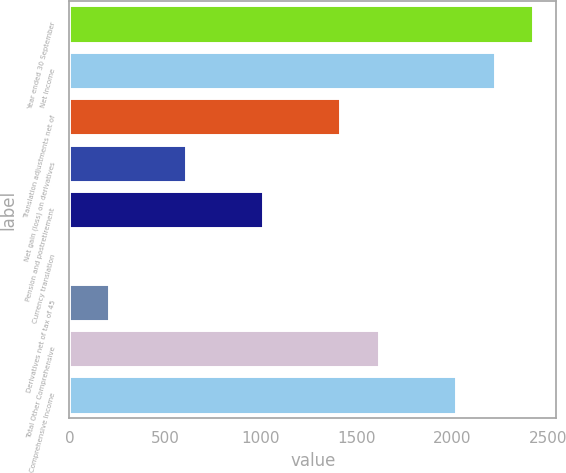Convert chart. <chart><loc_0><loc_0><loc_500><loc_500><bar_chart><fcel>Year ended 30 September<fcel>Net Income<fcel>Translation adjustments net of<fcel>Net gain (loss) on derivatives<fcel>Pension and postretirement<fcel>Currency translation<fcel>Derivatives net of tax of 45<fcel>Total Other Comprehensive<fcel>Comprehensive Income<nl><fcel>2422.28<fcel>2220.64<fcel>1414.08<fcel>607.52<fcel>1010.8<fcel>2.6<fcel>204.24<fcel>1615.72<fcel>2019<nl></chart> 